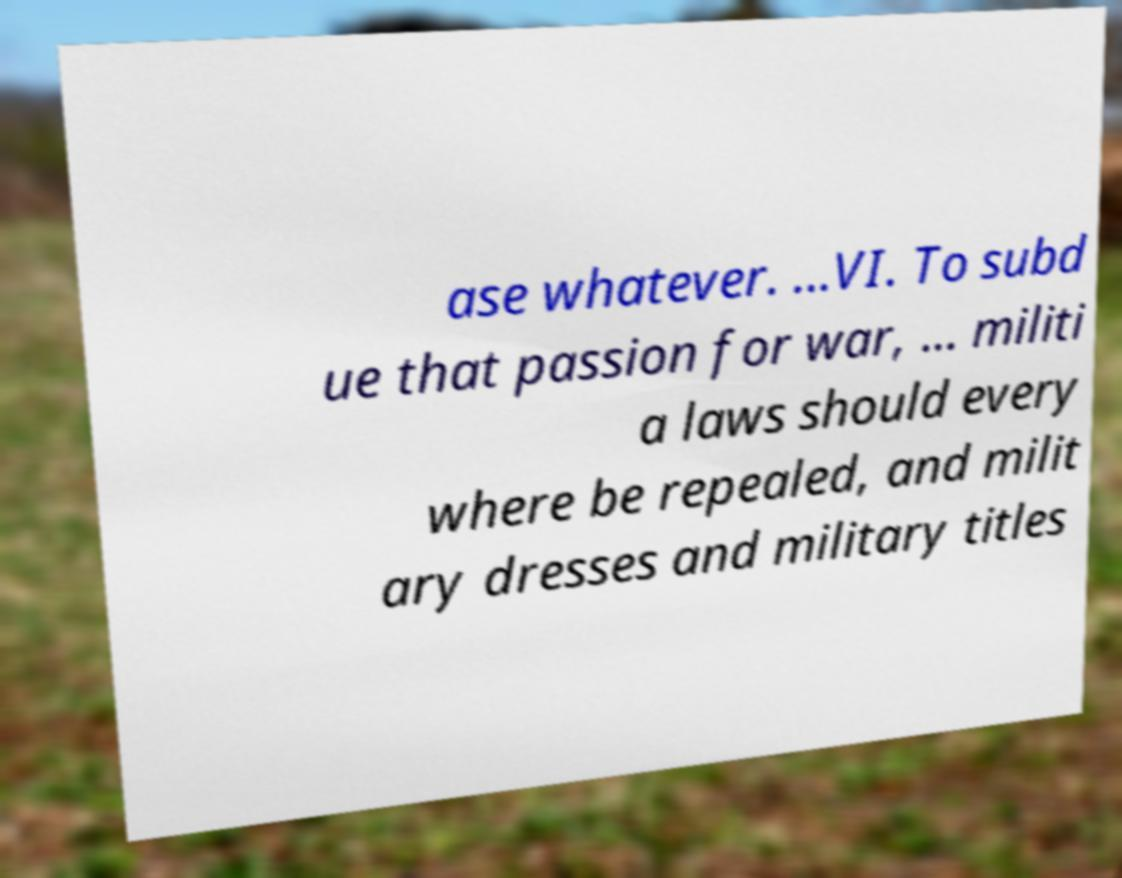For documentation purposes, I need the text within this image transcribed. Could you provide that? ase whatever. ...VI. To subd ue that passion for war, ... militi a laws should every where be repealed, and milit ary dresses and military titles 